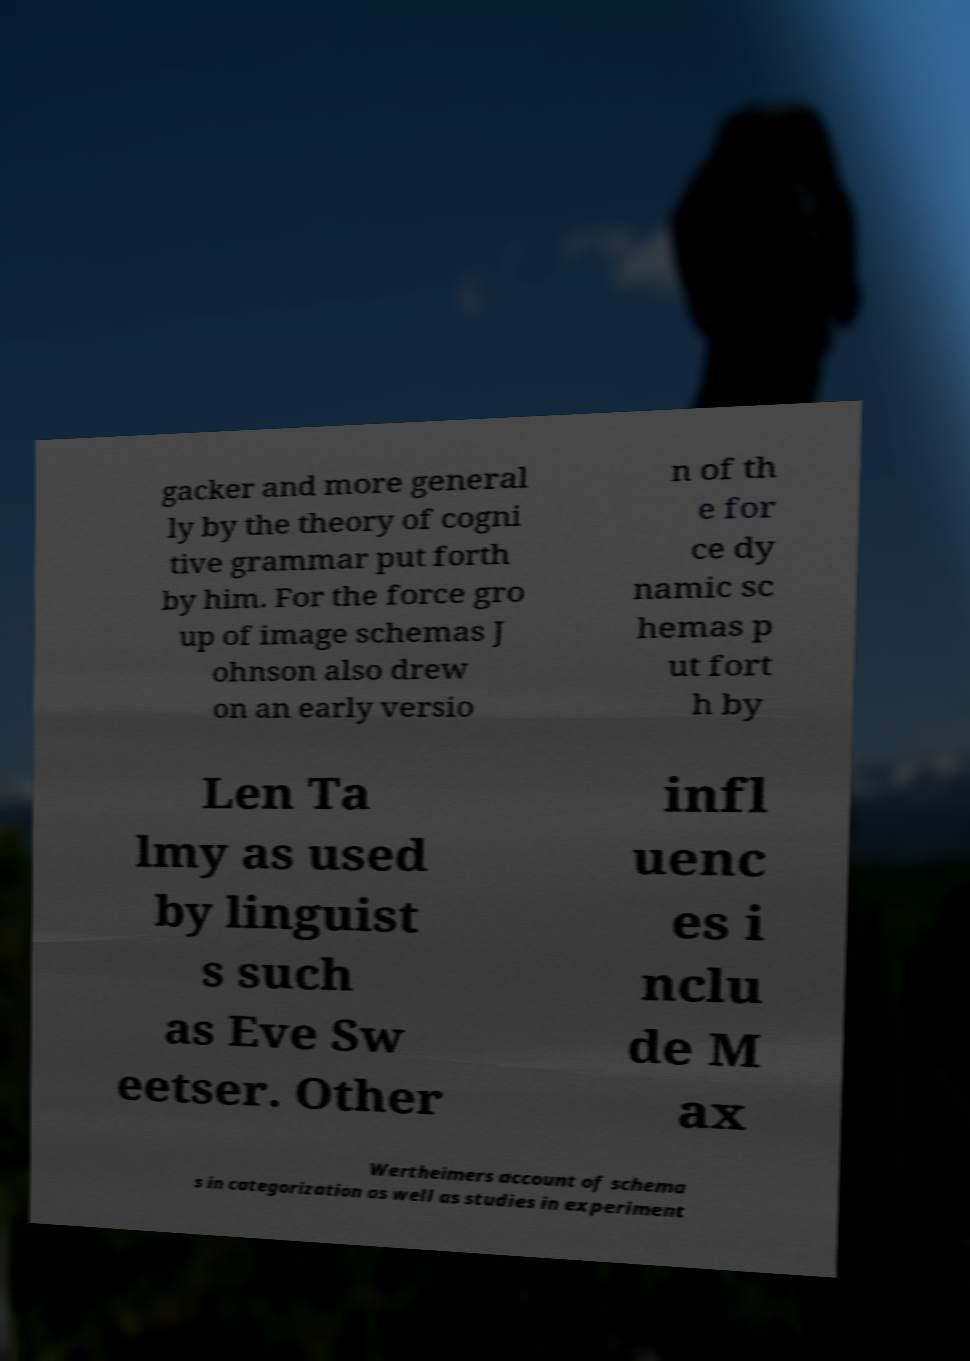Could you extract and type out the text from this image? gacker and more general ly by the theory of cogni tive grammar put forth by him. For the force gro up of image schemas J ohnson also drew on an early versio n of th e for ce dy namic sc hemas p ut fort h by Len Ta lmy as used by linguist s such as Eve Sw eetser. Other infl uenc es i nclu de M ax Wertheimers account of schema s in categorization as well as studies in experiment 